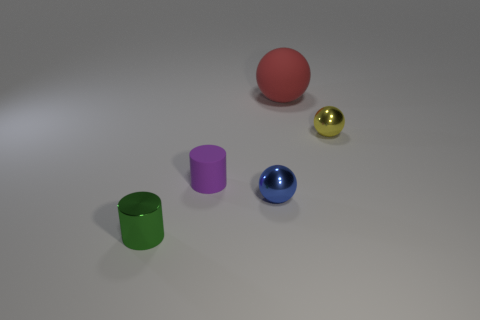What number of green matte blocks are the same size as the blue metal ball?
Make the answer very short. 0. What material is the other thing that is the same shape as the purple thing?
Keep it short and to the point. Metal. What is the color of the tiny thing to the left of the small matte thing?
Provide a succinct answer. Green. Are there more small things that are on the right side of the blue shiny object than metal objects?
Offer a very short reply. No. What color is the big rubber sphere?
Your answer should be very brief. Red. What is the shape of the matte thing in front of the shiny object behind the small cylinder right of the small green object?
Your response must be concise. Cylinder. What is the material of the thing that is behind the blue metal sphere and in front of the small yellow sphere?
Your response must be concise. Rubber. What is the shape of the rubber thing that is to the right of the small metal ball in front of the small purple cylinder?
Offer a terse response. Sphere. Is there anything else of the same color as the matte cylinder?
Ensure brevity in your answer.  No. Is the size of the matte sphere the same as the metallic object behind the small blue metallic ball?
Offer a terse response. No. 